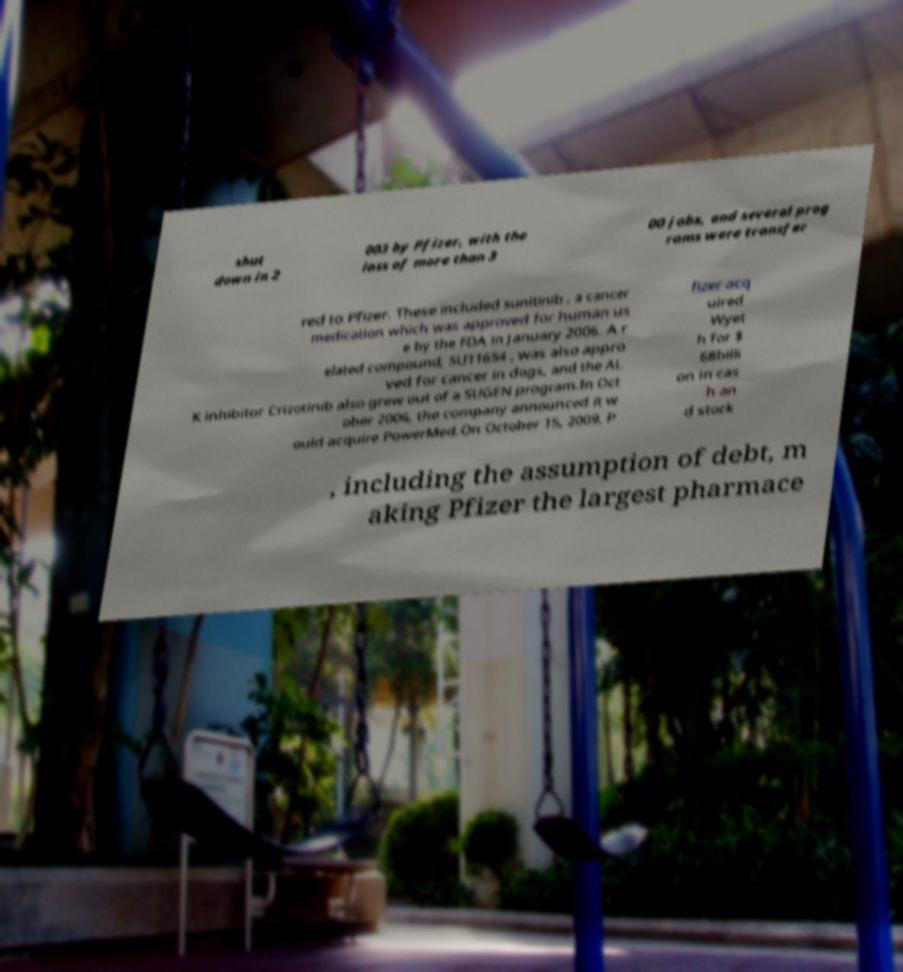What messages or text are displayed in this image? I need them in a readable, typed format. shut down in 2 003 by Pfizer, with the loss of more than 3 00 jobs, and several prog rams were transfer red to Pfizer. These included sunitinib , a cancer medication which was approved for human us e by the FDA in January 2006. A r elated compound, SU11654 , was also appro ved for cancer in dogs, and the AL K inhibitor Crizotinib also grew out of a SUGEN program.In Oct ober 2006, the company announced it w ould acquire PowerMed.On October 15, 2009, P fizer acq uired Wyet h for $ 68billi on in cas h an d stock , including the assumption of debt, m aking Pfizer the largest pharmace 